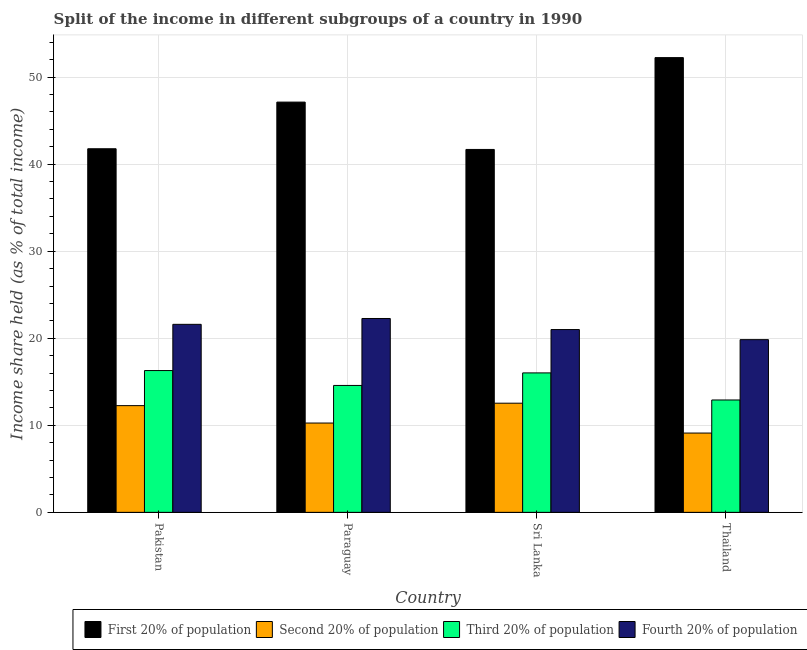How many different coloured bars are there?
Your answer should be compact. 4. Are the number of bars per tick equal to the number of legend labels?
Ensure brevity in your answer.  Yes. Are the number of bars on each tick of the X-axis equal?
Ensure brevity in your answer.  Yes. How many bars are there on the 2nd tick from the left?
Your response must be concise. 4. How many bars are there on the 3rd tick from the right?
Your answer should be compact. 4. What is the label of the 4th group of bars from the left?
Your answer should be very brief. Thailand. What is the share of the income held by third 20% of the population in Thailand?
Keep it short and to the point. 12.91. Across all countries, what is the maximum share of the income held by third 20% of the population?
Your response must be concise. 16.29. Across all countries, what is the minimum share of the income held by first 20% of the population?
Make the answer very short. 41.69. In which country was the share of the income held by first 20% of the population minimum?
Offer a very short reply. Sri Lanka. What is the total share of the income held by first 20% of the population in the graph?
Ensure brevity in your answer.  182.83. What is the difference between the share of the income held by fourth 20% of the population in Paraguay and the share of the income held by third 20% of the population in Pakistan?
Provide a short and direct response. 5.98. What is the average share of the income held by third 20% of the population per country?
Make the answer very short. 14.95. What is the difference between the share of the income held by second 20% of the population and share of the income held by fourth 20% of the population in Pakistan?
Your answer should be very brief. -9.34. What is the ratio of the share of the income held by first 20% of the population in Pakistan to that in Thailand?
Your answer should be very brief. 0.8. Is the difference between the share of the income held by fourth 20% of the population in Pakistan and Paraguay greater than the difference between the share of the income held by first 20% of the population in Pakistan and Paraguay?
Offer a very short reply. Yes. What is the difference between the highest and the second highest share of the income held by third 20% of the population?
Provide a succinct answer. 0.27. What is the difference between the highest and the lowest share of the income held by third 20% of the population?
Make the answer very short. 3.38. Is the sum of the share of the income held by first 20% of the population in Pakistan and Thailand greater than the maximum share of the income held by fourth 20% of the population across all countries?
Keep it short and to the point. Yes. Is it the case that in every country, the sum of the share of the income held by first 20% of the population and share of the income held by fourth 20% of the population is greater than the sum of share of the income held by second 20% of the population and share of the income held by third 20% of the population?
Provide a short and direct response. No. What does the 1st bar from the left in Pakistan represents?
Offer a very short reply. First 20% of population. What does the 2nd bar from the right in Pakistan represents?
Provide a short and direct response. Third 20% of population. Is it the case that in every country, the sum of the share of the income held by first 20% of the population and share of the income held by second 20% of the population is greater than the share of the income held by third 20% of the population?
Provide a succinct answer. Yes. How many countries are there in the graph?
Your response must be concise. 4. Does the graph contain any zero values?
Your response must be concise. No. Does the graph contain grids?
Provide a short and direct response. Yes. How are the legend labels stacked?
Your response must be concise. Horizontal. What is the title of the graph?
Offer a very short reply. Split of the income in different subgroups of a country in 1990. Does "Revenue mobilization" appear as one of the legend labels in the graph?
Provide a succinct answer. No. What is the label or title of the X-axis?
Provide a succinct answer. Country. What is the label or title of the Y-axis?
Provide a succinct answer. Income share held (as % of total income). What is the Income share held (as % of total income) of First 20% of population in Pakistan?
Provide a succinct answer. 41.77. What is the Income share held (as % of total income) of Second 20% of population in Pakistan?
Make the answer very short. 12.26. What is the Income share held (as % of total income) in Third 20% of population in Pakistan?
Provide a succinct answer. 16.29. What is the Income share held (as % of total income) of Fourth 20% of population in Pakistan?
Give a very brief answer. 21.6. What is the Income share held (as % of total income) of First 20% of population in Paraguay?
Provide a succinct answer. 47.13. What is the Income share held (as % of total income) in Second 20% of population in Paraguay?
Provide a succinct answer. 10.26. What is the Income share held (as % of total income) of Third 20% of population in Paraguay?
Make the answer very short. 14.58. What is the Income share held (as % of total income) of Fourth 20% of population in Paraguay?
Your answer should be very brief. 22.27. What is the Income share held (as % of total income) of First 20% of population in Sri Lanka?
Your response must be concise. 41.69. What is the Income share held (as % of total income) in Second 20% of population in Sri Lanka?
Give a very brief answer. 12.54. What is the Income share held (as % of total income) in Third 20% of population in Sri Lanka?
Provide a short and direct response. 16.02. What is the Income share held (as % of total income) of Fourth 20% of population in Sri Lanka?
Give a very brief answer. 21. What is the Income share held (as % of total income) in First 20% of population in Thailand?
Give a very brief answer. 52.24. What is the Income share held (as % of total income) in Second 20% of population in Thailand?
Provide a succinct answer. 9.11. What is the Income share held (as % of total income) of Third 20% of population in Thailand?
Give a very brief answer. 12.91. What is the Income share held (as % of total income) in Fourth 20% of population in Thailand?
Your answer should be very brief. 19.84. Across all countries, what is the maximum Income share held (as % of total income) of First 20% of population?
Your response must be concise. 52.24. Across all countries, what is the maximum Income share held (as % of total income) of Second 20% of population?
Offer a terse response. 12.54. Across all countries, what is the maximum Income share held (as % of total income) in Third 20% of population?
Your answer should be very brief. 16.29. Across all countries, what is the maximum Income share held (as % of total income) of Fourth 20% of population?
Keep it short and to the point. 22.27. Across all countries, what is the minimum Income share held (as % of total income) of First 20% of population?
Your response must be concise. 41.69. Across all countries, what is the minimum Income share held (as % of total income) of Second 20% of population?
Your answer should be very brief. 9.11. Across all countries, what is the minimum Income share held (as % of total income) of Third 20% of population?
Your answer should be compact. 12.91. Across all countries, what is the minimum Income share held (as % of total income) in Fourth 20% of population?
Provide a short and direct response. 19.84. What is the total Income share held (as % of total income) in First 20% of population in the graph?
Make the answer very short. 182.83. What is the total Income share held (as % of total income) of Second 20% of population in the graph?
Give a very brief answer. 44.17. What is the total Income share held (as % of total income) of Third 20% of population in the graph?
Your answer should be very brief. 59.8. What is the total Income share held (as % of total income) of Fourth 20% of population in the graph?
Offer a very short reply. 84.71. What is the difference between the Income share held (as % of total income) of First 20% of population in Pakistan and that in Paraguay?
Keep it short and to the point. -5.36. What is the difference between the Income share held (as % of total income) in Third 20% of population in Pakistan and that in Paraguay?
Your answer should be compact. 1.71. What is the difference between the Income share held (as % of total income) of Fourth 20% of population in Pakistan and that in Paraguay?
Your answer should be compact. -0.67. What is the difference between the Income share held (as % of total income) in Second 20% of population in Pakistan and that in Sri Lanka?
Ensure brevity in your answer.  -0.28. What is the difference between the Income share held (as % of total income) of Third 20% of population in Pakistan and that in Sri Lanka?
Offer a terse response. 0.27. What is the difference between the Income share held (as % of total income) in First 20% of population in Pakistan and that in Thailand?
Ensure brevity in your answer.  -10.47. What is the difference between the Income share held (as % of total income) in Second 20% of population in Pakistan and that in Thailand?
Your answer should be very brief. 3.15. What is the difference between the Income share held (as % of total income) of Third 20% of population in Pakistan and that in Thailand?
Offer a terse response. 3.38. What is the difference between the Income share held (as % of total income) of Fourth 20% of population in Pakistan and that in Thailand?
Keep it short and to the point. 1.76. What is the difference between the Income share held (as % of total income) of First 20% of population in Paraguay and that in Sri Lanka?
Keep it short and to the point. 5.44. What is the difference between the Income share held (as % of total income) in Second 20% of population in Paraguay and that in Sri Lanka?
Offer a very short reply. -2.28. What is the difference between the Income share held (as % of total income) of Third 20% of population in Paraguay and that in Sri Lanka?
Ensure brevity in your answer.  -1.44. What is the difference between the Income share held (as % of total income) of Fourth 20% of population in Paraguay and that in Sri Lanka?
Offer a very short reply. 1.27. What is the difference between the Income share held (as % of total income) of First 20% of population in Paraguay and that in Thailand?
Ensure brevity in your answer.  -5.11. What is the difference between the Income share held (as % of total income) of Second 20% of population in Paraguay and that in Thailand?
Your response must be concise. 1.15. What is the difference between the Income share held (as % of total income) in Third 20% of population in Paraguay and that in Thailand?
Offer a very short reply. 1.67. What is the difference between the Income share held (as % of total income) of Fourth 20% of population in Paraguay and that in Thailand?
Provide a short and direct response. 2.43. What is the difference between the Income share held (as % of total income) in First 20% of population in Sri Lanka and that in Thailand?
Your response must be concise. -10.55. What is the difference between the Income share held (as % of total income) in Second 20% of population in Sri Lanka and that in Thailand?
Ensure brevity in your answer.  3.43. What is the difference between the Income share held (as % of total income) in Third 20% of population in Sri Lanka and that in Thailand?
Ensure brevity in your answer.  3.11. What is the difference between the Income share held (as % of total income) in Fourth 20% of population in Sri Lanka and that in Thailand?
Your answer should be very brief. 1.16. What is the difference between the Income share held (as % of total income) in First 20% of population in Pakistan and the Income share held (as % of total income) in Second 20% of population in Paraguay?
Offer a terse response. 31.51. What is the difference between the Income share held (as % of total income) of First 20% of population in Pakistan and the Income share held (as % of total income) of Third 20% of population in Paraguay?
Offer a terse response. 27.19. What is the difference between the Income share held (as % of total income) in Second 20% of population in Pakistan and the Income share held (as % of total income) in Third 20% of population in Paraguay?
Ensure brevity in your answer.  -2.32. What is the difference between the Income share held (as % of total income) of Second 20% of population in Pakistan and the Income share held (as % of total income) of Fourth 20% of population in Paraguay?
Give a very brief answer. -10.01. What is the difference between the Income share held (as % of total income) in Third 20% of population in Pakistan and the Income share held (as % of total income) in Fourth 20% of population in Paraguay?
Ensure brevity in your answer.  -5.98. What is the difference between the Income share held (as % of total income) of First 20% of population in Pakistan and the Income share held (as % of total income) of Second 20% of population in Sri Lanka?
Give a very brief answer. 29.23. What is the difference between the Income share held (as % of total income) of First 20% of population in Pakistan and the Income share held (as % of total income) of Third 20% of population in Sri Lanka?
Provide a short and direct response. 25.75. What is the difference between the Income share held (as % of total income) in First 20% of population in Pakistan and the Income share held (as % of total income) in Fourth 20% of population in Sri Lanka?
Keep it short and to the point. 20.77. What is the difference between the Income share held (as % of total income) in Second 20% of population in Pakistan and the Income share held (as % of total income) in Third 20% of population in Sri Lanka?
Ensure brevity in your answer.  -3.76. What is the difference between the Income share held (as % of total income) in Second 20% of population in Pakistan and the Income share held (as % of total income) in Fourth 20% of population in Sri Lanka?
Offer a very short reply. -8.74. What is the difference between the Income share held (as % of total income) of Third 20% of population in Pakistan and the Income share held (as % of total income) of Fourth 20% of population in Sri Lanka?
Ensure brevity in your answer.  -4.71. What is the difference between the Income share held (as % of total income) in First 20% of population in Pakistan and the Income share held (as % of total income) in Second 20% of population in Thailand?
Provide a short and direct response. 32.66. What is the difference between the Income share held (as % of total income) in First 20% of population in Pakistan and the Income share held (as % of total income) in Third 20% of population in Thailand?
Give a very brief answer. 28.86. What is the difference between the Income share held (as % of total income) in First 20% of population in Pakistan and the Income share held (as % of total income) in Fourth 20% of population in Thailand?
Ensure brevity in your answer.  21.93. What is the difference between the Income share held (as % of total income) of Second 20% of population in Pakistan and the Income share held (as % of total income) of Third 20% of population in Thailand?
Offer a very short reply. -0.65. What is the difference between the Income share held (as % of total income) of Second 20% of population in Pakistan and the Income share held (as % of total income) of Fourth 20% of population in Thailand?
Offer a very short reply. -7.58. What is the difference between the Income share held (as % of total income) of Third 20% of population in Pakistan and the Income share held (as % of total income) of Fourth 20% of population in Thailand?
Provide a succinct answer. -3.55. What is the difference between the Income share held (as % of total income) of First 20% of population in Paraguay and the Income share held (as % of total income) of Second 20% of population in Sri Lanka?
Provide a short and direct response. 34.59. What is the difference between the Income share held (as % of total income) in First 20% of population in Paraguay and the Income share held (as % of total income) in Third 20% of population in Sri Lanka?
Provide a succinct answer. 31.11. What is the difference between the Income share held (as % of total income) of First 20% of population in Paraguay and the Income share held (as % of total income) of Fourth 20% of population in Sri Lanka?
Offer a terse response. 26.13. What is the difference between the Income share held (as % of total income) in Second 20% of population in Paraguay and the Income share held (as % of total income) in Third 20% of population in Sri Lanka?
Offer a very short reply. -5.76. What is the difference between the Income share held (as % of total income) of Second 20% of population in Paraguay and the Income share held (as % of total income) of Fourth 20% of population in Sri Lanka?
Offer a terse response. -10.74. What is the difference between the Income share held (as % of total income) of Third 20% of population in Paraguay and the Income share held (as % of total income) of Fourth 20% of population in Sri Lanka?
Offer a terse response. -6.42. What is the difference between the Income share held (as % of total income) in First 20% of population in Paraguay and the Income share held (as % of total income) in Second 20% of population in Thailand?
Your answer should be very brief. 38.02. What is the difference between the Income share held (as % of total income) of First 20% of population in Paraguay and the Income share held (as % of total income) of Third 20% of population in Thailand?
Keep it short and to the point. 34.22. What is the difference between the Income share held (as % of total income) in First 20% of population in Paraguay and the Income share held (as % of total income) in Fourth 20% of population in Thailand?
Ensure brevity in your answer.  27.29. What is the difference between the Income share held (as % of total income) in Second 20% of population in Paraguay and the Income share held (as % of total income) in Third 20% of population in Thailand?
Provide a short and direct response. -2.65. What is the difference between the Income share held (as % of total income) in Second 20% of population in Paraguay and the Income share held (as % of total income) in Fourth 20% of population in Thailand?
Ensure brevity in your answer.  -9.58. What is the difference between the Income share held (as % of total income) in Third 20% of population in Paraguay and the Income share held (as % of total income) in Fourth 20% of population in Thailand?
Ensure brevity in your answer.  -5.26. What is the difference between the Income share held (as % of total income) in First 20% of population in Sri Lanka and the Income share held (as % of total income) in Second 20% of population in Thailand?
Offer a terse response. 32.58. What is the difference between the Income share held (as % of total income) of First 20% of population in Sri Lanka and the Income share held (as % of total income) of Third 20% of population in Thailand?
Provide a succinct answer. 28.78. What is the difference between the Income share held (as % of total income) in First 20% of population in Sri Lanka and the Income share held (as % of total income) in Fourth 20% of population in Thailand?
Your answer should be very brief. 21.85. What is the difference between the Income share held (as % of total income) of Second 20% of population in Sri Lanka and the Income share held (as % of total income) of Third 20% of population in Thailand?
Provide a short and direct response. -0.37. What is the difference between the Income share held (as % of total income) of Second 20% of population in Sri Lanka and the Income share held (as % of total income) of Fourth 20% of population in Thailand?
Offer a very short reply. -7.3. What is the difference between the Income share held (as % of total income) in Third 20% of population in Sri Lanka and the Income share held (as % of total income) in Fourth 20% of population in Thailand?
Offer a very short reply. -3.82. What is the average Income share held (as % of total income) in First 20% of population per country?
Provide a succinct answer. 45.71. What is the average Income share held (as % of total income) of Second 20% of population per country?
Your response must be concise. 11.04. What is the average Income share held (as % of total income) in Third 20% of population per country?
Ensure brevity in your answer.  14.95. What is the average Income share held (as % of total income) of Fourth 20% of population per country?
Your answer should be compact. 21.18. What is the difference between the Income share held (as % of total income) in First 20% of population and Income share held (as % of total income) in Second 20% of population in Pakistan?
Your response must be concise. 29.51. What is the difference between the Income share held (as % of total income) of First 20% of population and Income share held (as % of total income) of Third 20% of population in Pakistan?
Provide a short and direct response. 25.48. What is the difference between the Income share held (as % of total income) in First 20% of population and Income share held (as % of total income) in Fourth 20% of population in Pakistan?
Ensure brevity in your answer.  20.17. What is the difference between the Income share held (as % of total income) in Second 20% of population and Income share held (as % of total income) in Third 20% of population in Pakistan?
Offer a terse response. -4.03. What is the difference between the Income share held (as % of total income) of Second 20% of population and Income share held (as % of total income) of Fourth 20% of population in Pakistan?
Your response must be concise. -9.34. What is the difference between the Income share held (as % of total income) in Third 20% of population and Income share held (as % of total income) in Fourth 20% of population in Pakistan?
Provide a short and direct response. -5.31. What is the difference between the Income share held (as % of total income) in First 20% of population and Income share held (as % of total income) in Second 20% of population in Paraguay?
Ensure brevity in your answer.  36.87. What is the difference between the Income share held (as % of total income) of First 20% of population and Income share held (as % of total income) of Third 20% of population in Paraguay?
Offer a terse response. 32.55. What is the difference between the Income share held (as % of total income) in First 20% of population and Income share held (as % of total income) in Fourth 20% of population in Paraguay?
Give a very brief answer. 24.86. What is the difference between the Income share held (as % of total income) of Second 20% of population and Income share held (as % of total income) of Third 20% of population in Paraguay?
Provide a short and direct response. -4.32. What is the difference between the Income share held (as % of total income) in Second 20% of population and Income share held (as % of total income) in Fourth 20% of population in Paraguay?
Offer a very short reply. -12.01. What is the difference between the Income share held (as % of total income) of Third 20% of population and Income share held (as % of total income) of Fourth 20% of population in Paraguay?
Your response must be concise. -7.69. What is the difference between the Income share held (as % of total income) of First 20% of population and Income share held (as % of total income) of Second 20% of population in Sri Lanka?
Provide a short and direct response. 29.15. What is the difference between the Income share held (as % of total income) of First 20% of population and Income share held (as % of total income) of Third 20% of population in Sri Lanka?
Offer a very short reply. 25.67. What is the difference between the Income share held (as % of total income) of First 20% of population and Income share held (as % of total income) of Fourth 20% of population in Sri Lanka?
Provide a short and direct response. 20.69. What is the difference between the Income share held (as % of total income) of Second 20% of population and Income share held (as % of total income) of Third 20% of population in Sri Lanka?
Give a very brief answer. -3.48. What is the difference between the Income share held (as % of total income) of Second 20% of population and Income share held (as % of total income) of Fourth 20% of population in Sri Lanka?
Offer a very short reply. -8.46. What is the difference between the Income share held (as % of total income) of Third 20% of population and Income share held (as % of total income) of Fourth 20% of population in Sri Lanka?
Offer a terse response. -4.98. What is the difference between the Income share held (as % of total income) of First 20% of population and Income share held (as % of total income) of Second 20% of population in Thailand?
Offer a terse response. 43.13. What is the difference between the Income share held (as % of total income) of First 20% of population and Income share held (as % of total income) of Third 20% of population in Thailand?
Your response must be concise. 39.33. What is the difference between the Income share held (as % of total income) of First 20% of population and Income share held (as % of total income) of Fourth 20% of population in Thailand?
Provide a short and direct response. 32.4. What is the difference between the Income share held (as % of total income) in Second 20% of population and Income share held (as % of total income) in Third 20% of population in Thailand?
Provide a short and direct response. -3.8. What is the difference between the Income share held (as % of total income) in Second 20% of population and Income share held (as % of total income) in Fourth 20% of population in Thailand?
Your answer should be very brief. -10.73. What is the difference between the Income share held (as % of total income) in Third 20% of population and Income share held (as % of total income) in Fourth 20% of population in Thailand?
Make the answer very short. -6.93. What is the ratio of the Income share held (as % of total income) of First 20% of population in Pakistan to that in Paraguay?
Your answer should be very brief. 0.89. What is the ratio of the Income share held (as % of total income) in Second 20% of population in Pakistan to that in Paraguay?
Your answer should be very brief. 1.19. What is the ratio of the Income share held (as % of total income) of Third 20% of population in Pakistan to that in Paraguay?
Ensure brevity in your answer.  1.12. What is the ratio of the Income share held (as % of total income) of Fourth 20% of population in Pakistan to that in Paraguay?
Your answer should be very brief. 0.97. What is the ratio of the Income share held (as % of total income) in Second 20% of population in Pakistan to that in Sri Lanka?
Ensure brevity in your answer.  0.98. What is the ratio of the Income share held (as % of total income) of Third 20% of population in Pakistan to that in Sri Lanka?
Your answer should be compact. 1.02. What is the ratio of the Income share held (as % of total income) of Fourth 20% of population in Pakistan to that in Sri Lanka?
Offer a terse response. 1.03. What is the ratio of the Income share held (as % of total income) of First 20% of population in Pakistan to that in Thailand?
Provide a short and direct response. 0.8. What is the ratio of the Income share held (as % of total income) in Second 20% of population in Pakistan to that in Thailand?
Ensure brevity in your answer.  1.35. What is the ratio of the Income share held (as % of total income) of Third 20% of population in Pakistan to that in Thailand?
Your response must be concise. 1.26. What is the ratio of the Income share held (as % of total income) of Fourth 20% of population in Pakistan to that in Thailand?
Make the answer very short. 1.09. What is the ratio of the Income share held (as % of total income) of First 20% of population in Paraguay to that in Sri Lanka?
Your answer should be compact. 1.13. What is the ratio of the Income share held (as % of total income) in Second 20% of population in Paraguay to that in Sri Lanka?
Provide a succinct answer. 0.82. What is the ratio of the Income share held (as % of total income) of Third 20% of population in Paraguay to that in Sri Lanka?
Provide a succinct answer. 0.91. What is the ratio of the Income share held (as % of total income) in Fourth 20% of population in Paraguay to that in Sri Lanka?
Provide a short and direct response. 1.06. What is the ratio of the Income share held (as % of total income) of First 20% of population in Paraguay to that in Thailand?
Offer a very short reply. 0.9. What is the ratio of the Income share held (as % of total income) in Second 20% of population in Paraguay to that in Thailand?
Keep it short and to the point. 1.13. What is the ratio of the Income share held (as % of total income) in Third 20% of population in Paraguay to that in Thailand?
Give a very brief answer. 1.13. What is the ratio of the Income share held (as % of total income) in Fourth 20% of population in Paraguay to that in Thailand?
Your answer should be very brief. 1.12. What is the ratio of the Income share held (as % of total income) of First 20% of population in Sri Lanka to that in Thailand?
Give a very brief answer. 0.8. What is the ratio of the Income share held (as % of total income) of Second 20% of population in Sri Lanka to that in Thailand?
Your answer should be compact. 1.38. What is the ratio of the Income share held (as % of total income) in Third 20% of population in Sri Lanka to that in Thailand?
Make the answer very short. 1.24. What is the ratio of the Income share held (as % of total income) of Fourth 20% of population in Sri Lanka to that in Thailand?
Offer a very short reply. 1.06. What is the difference between the highest and the second highest Income share held (as % of total income) of First 20% of population?
Offer a terse response. 5.11. What is the difference between the highest and the second highest Income share held (as % of total income) of Second 20% of population?
Your answer should be compact. 0.28. What is the difference between the highest and the second highest Income share held (as % of total income) of Third 20% of population?
Your response must be concise. 0.27. What is the difference between the highest and the second highest Income share held (as % of total income) of Fourth 20% of population?
Ensure brevity in your answer.  0.67. What is the difference between the highest and the lowest Income share held (as % of total income) in First 20% of population?
Your response must be concise. 10.55. What is the difference between the highest and the lowest Income share held (as % of total income) of Second 20% of population?
Offer a very short reply. 3.43. What is the difference between the highest and the lowest Income share held (as % of total income) of Third 20% of population?
Offer a terse response. 3.38. What is the difference between the highest and the lowest Income share held (as % of total income) in Fourth 20% of population?
Offer a terse response. 2.43. 